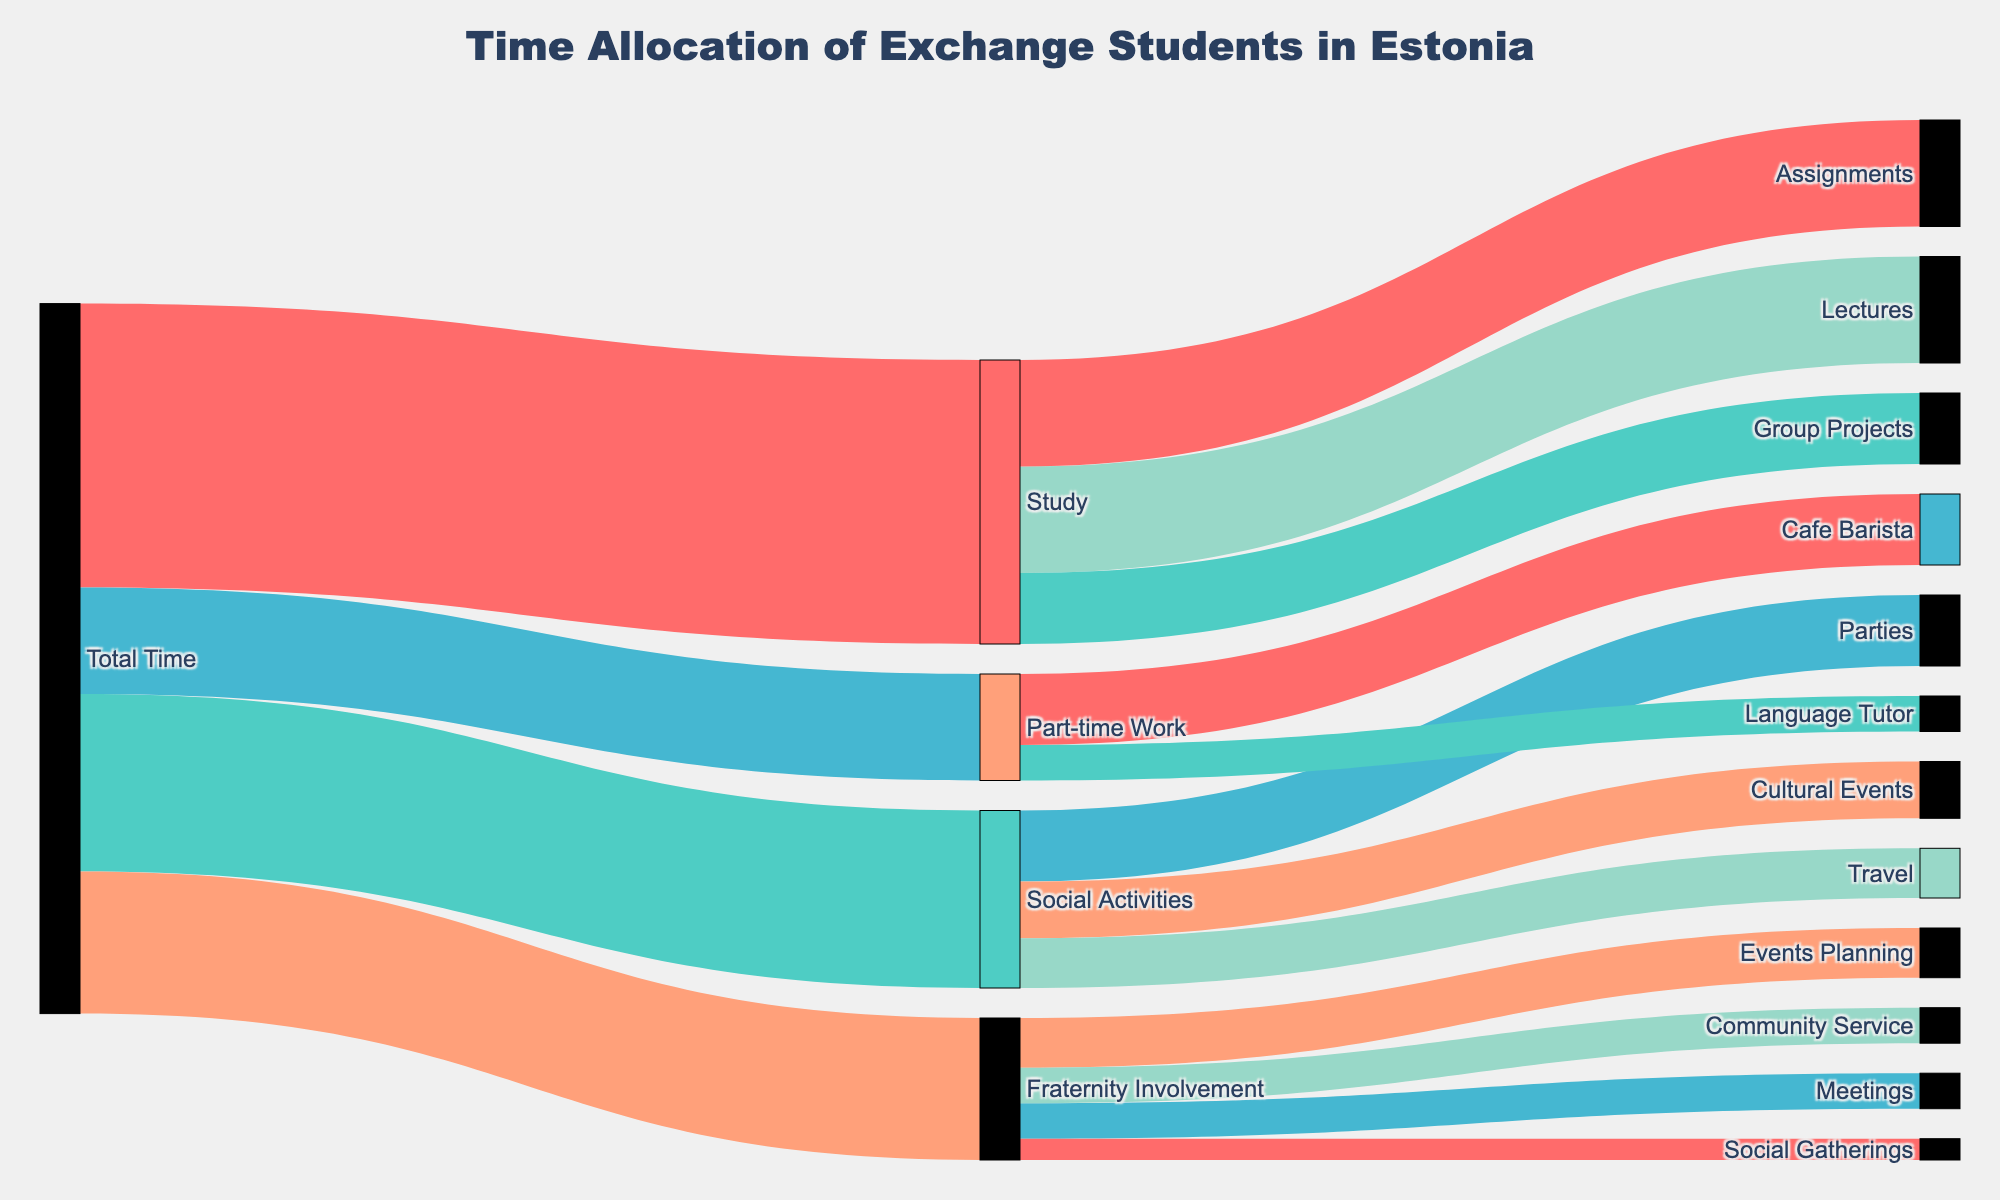what is the title of the figure? The title is located at the top center of the figure. It indicates what the figure is about. The title in this figure is "Time Allocation of Exchange Students in Estonia".
Answer: Time Allocation of Exchange Students in Estonia which activity has the most time allocated to it? To find which activity has the most time allocated, compare the values connected from the "Total Time" node to its immediate target nodes. Study has 40, Social Activities has 25, Part-time Work has 15, and Fraternity Involvement has 20.
Answer: Study how much total time is allocated to studying and social activities combined? To find the total time allocated to both studying and social activities, sum the time allocated to Study and Social Activities: 40 + 25.
Answer: 65 which specific study-related task takes up the most time? Look for the target nodes connected to the Study node and compare their values. Lectures have 15, Assignments have 15, and Group Projects have 10.
Answer: Lectures or Assignments how does the time allocated to social gatherings within fraternity involvement compare to community service? Look at the target nodes connected to Fraternity Involvement and compare Social Gatherings (3) and Community Service (5). Community Service is greater than Social Gatherings.
Answer: Community Service is greater than Social Gatherings what percentage of the total time is allocated to part-time work? To find this percentage, divide the time allocated to Part-time Work by Total Time and multiply by 100: (15/100) * 100 = 15%.
Answer: 15% how many hours are spent in fraternity involvement activities each week? Refer to the individual categories under Fraternity Involvement and sum the hours. 5 (Meetings) + 7 (Events Planning) + 5 (Community Service) + 3 (Social Gatherings) = 20.
Answer: 20 are lectures or assignments the bigger time sinks within study-related tasks? Compare the values for Lectures and Assignments under Study. Both have 15 hours, so they are equal.
Answer: They are equal how does the time spent on cultural events compare to time spent working as a language tutor? Compare the values for Cultural Events under Social Activities and Language Tutor under Part-time Work. Cultural Events have 8 and Language Tutor has 5.
Answer: Cultural Events have more time than Language Tutor if the time spent at a cafe barista were reduced by 50%, what would it be? Calculate 50% of the time allocated to Cafe Barista: 10 * 0.5 = 5 hours.
Answer: 5 hours 